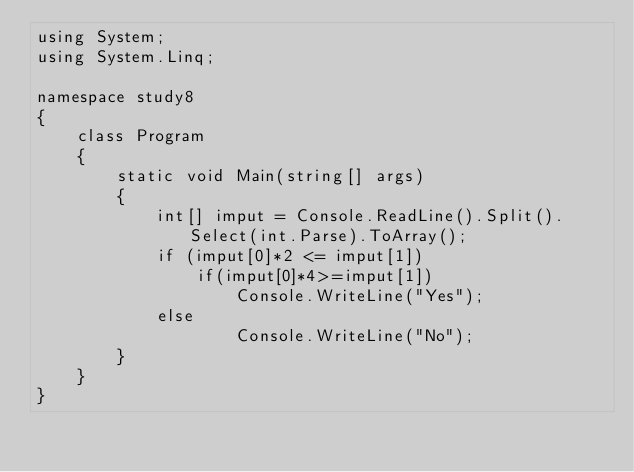<code> <loc_0><loc_0><loc_500><loc_500><_C#_>using System;
using System.Linq;

namespace study8
{
    class Program
    {
        static void Main(string[] args)
        {
            int[] imput = Console.ReadLine().Split().Select(int.Parse).ToArray();
            if (imput[0]*2 <= imput[1])
                if(imput[0]*4>=imput[1])
                    Console.WriteLine("Yes");
            else
                    Console.WriteLine("No");
        }
    }
}
</code> 